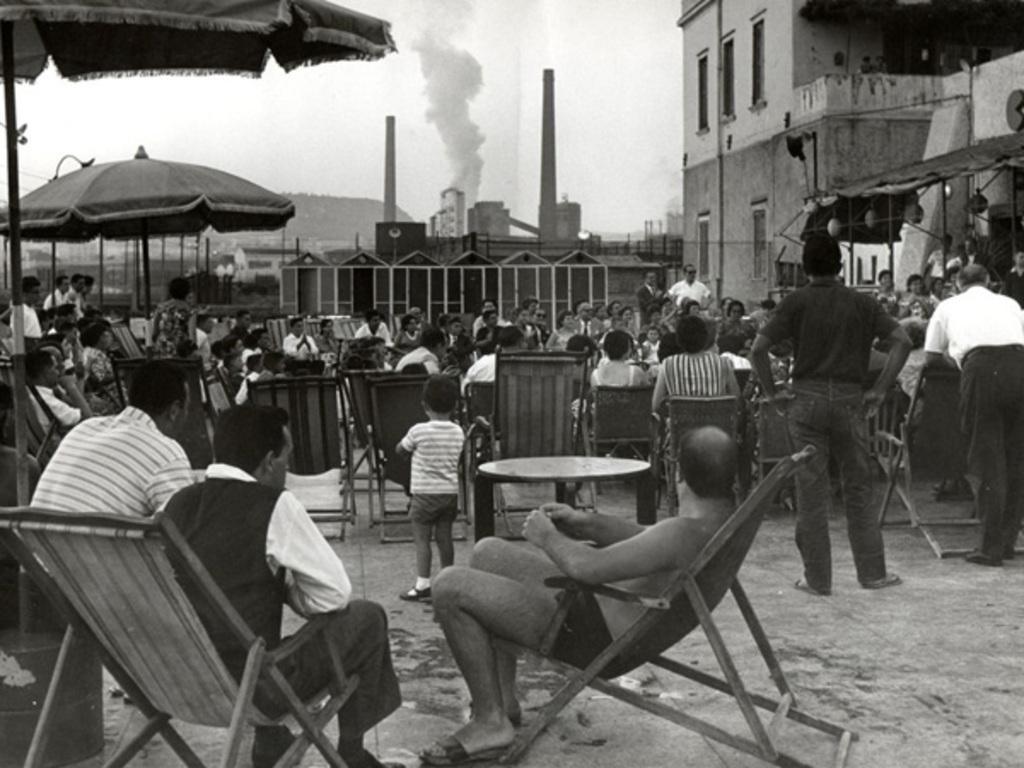Could you give a brief overview of what you see in this image? In this picture we can observe some people sitting in the chair under umbrellas. There are some people standing. We can observe a building on the right side. In the background we can observe smoke, two poles and a sky. This is a black and white image. 